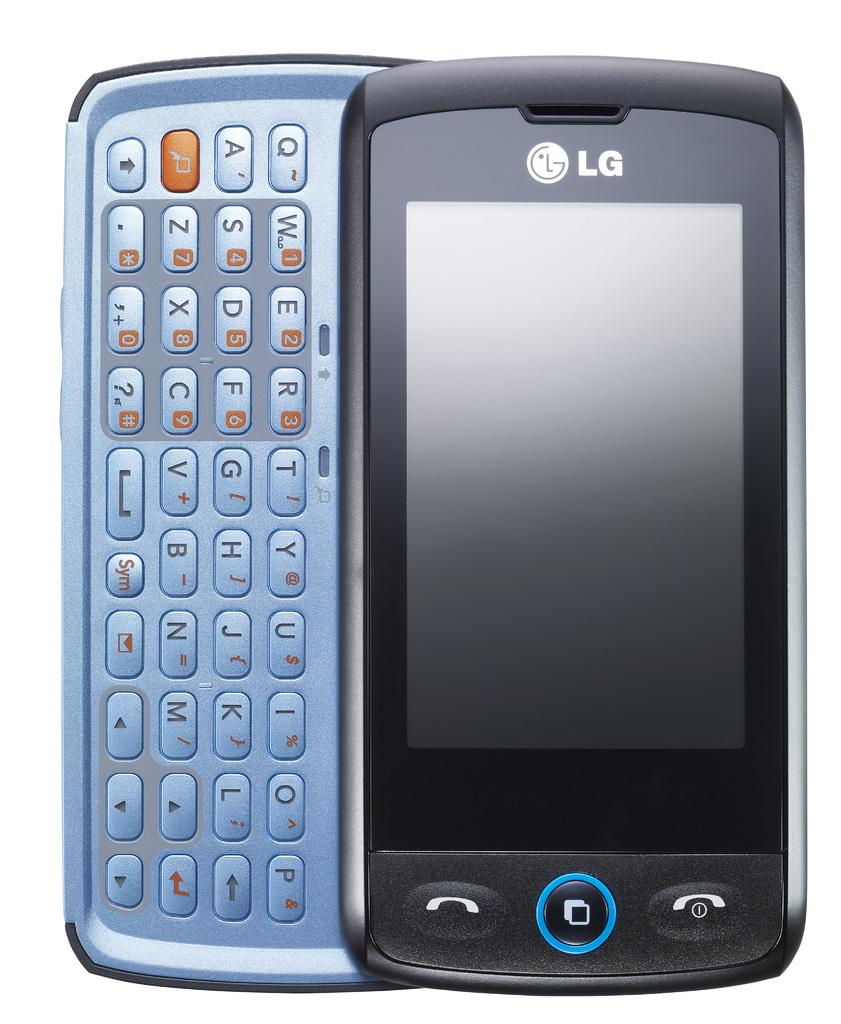<image>
Offer a succinct explanation of the picture presented. A black LG cell phone with a slide out keyboard. 